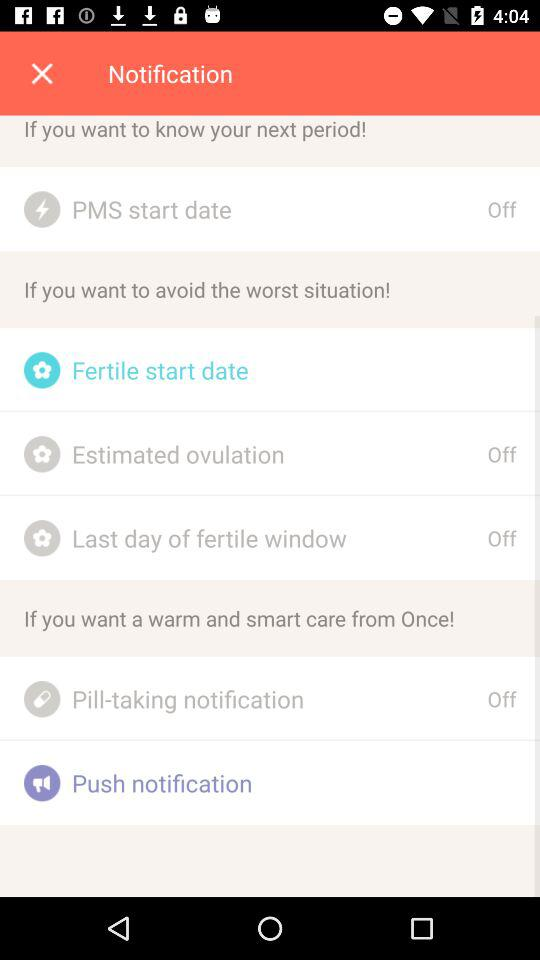What is the status of "PMS start date"? The status is "off". 